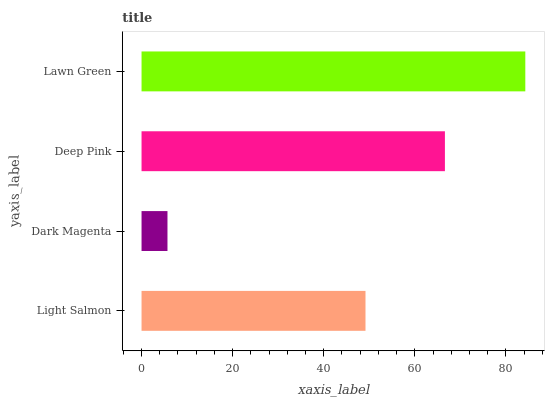Is Dark Magenta the minimum?
Answer yes or no. Yes. Is Lawn Green the maximum?
Answer yes or no. Yes. Is Deep Pink the minimum?
Answer yes or no. No. Is Deep Pink the maximum?
Answer yes or no. No. Is Deep Pink greater than Dark Magenta?
Answer yes or no. Yes. Is Dark Magenta less than Deep Pink?
Answer yes or no. Yes. Is Dark Magenta greater than Deep Pink?
Answer yes or no. No. Is Deep Pink less than Dark Magenta?
Answer yes or no. No. Is Deep Pink the high median?
Answer yes or no. Yes. Is Light Salmon the low median?
Answer yes or no. Yes. Is Light Salmon the high median?
Answer yes or no. No. Is Dark Magenta the low median?
Answer yes or no. No. 